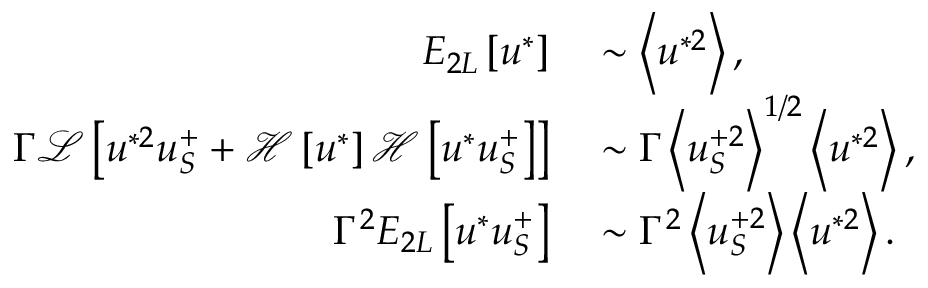Convert formula to latex. <formula><loc_0><loc_0><loc_500><loc_500>\begin{array} { r l } { E _ { 2 L } \left [ u ^ { * } \right ] } & \sim \left < u ^ { * 2 } \right > , } \\ { \Gamma \mathcal { L } \left [ u ^ { * 2 } u _ { S } ^ { + } + \mathcal { H } \left [ u ^ { * } \right ] \mathcal { H } \left [ u ^ { * } u _ { S } ^ { + } \right ] \right ] } & \sim \Gamma \left < u _ { S } ^ { + 2 } \right > ^ { 1 / 2 } \left < u ^ { * 2 } \right > , } \\ { \Gamma ^ { 2 } E _ { 2 L } \left [ u ^ { * } u _ { S } ^ { + } \right ] } & \sim \Gamma ^ { 2 } \left < u _ { S } ^ { + 2 } \right > \left < u ^ { * 2 } \right > . } \end{array}</formula> 